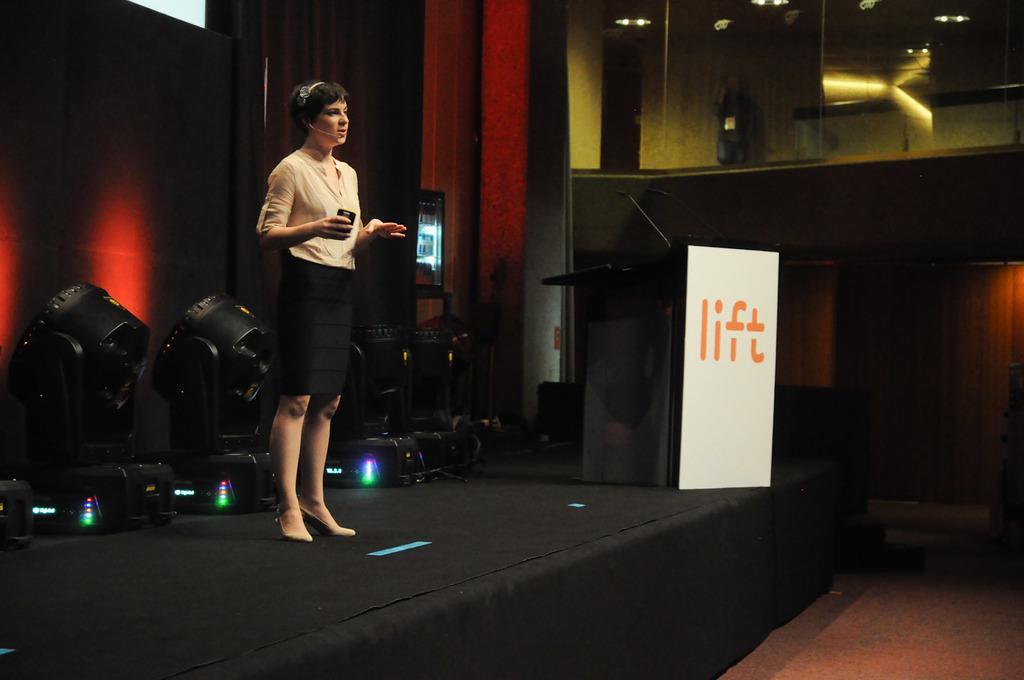Can you describe this image briefly? In this picture I can see a man standing and speaking and she is a holding something in her hand and I can see a podium with a microphone and I can see text on the board and few lights on the ceiling. 